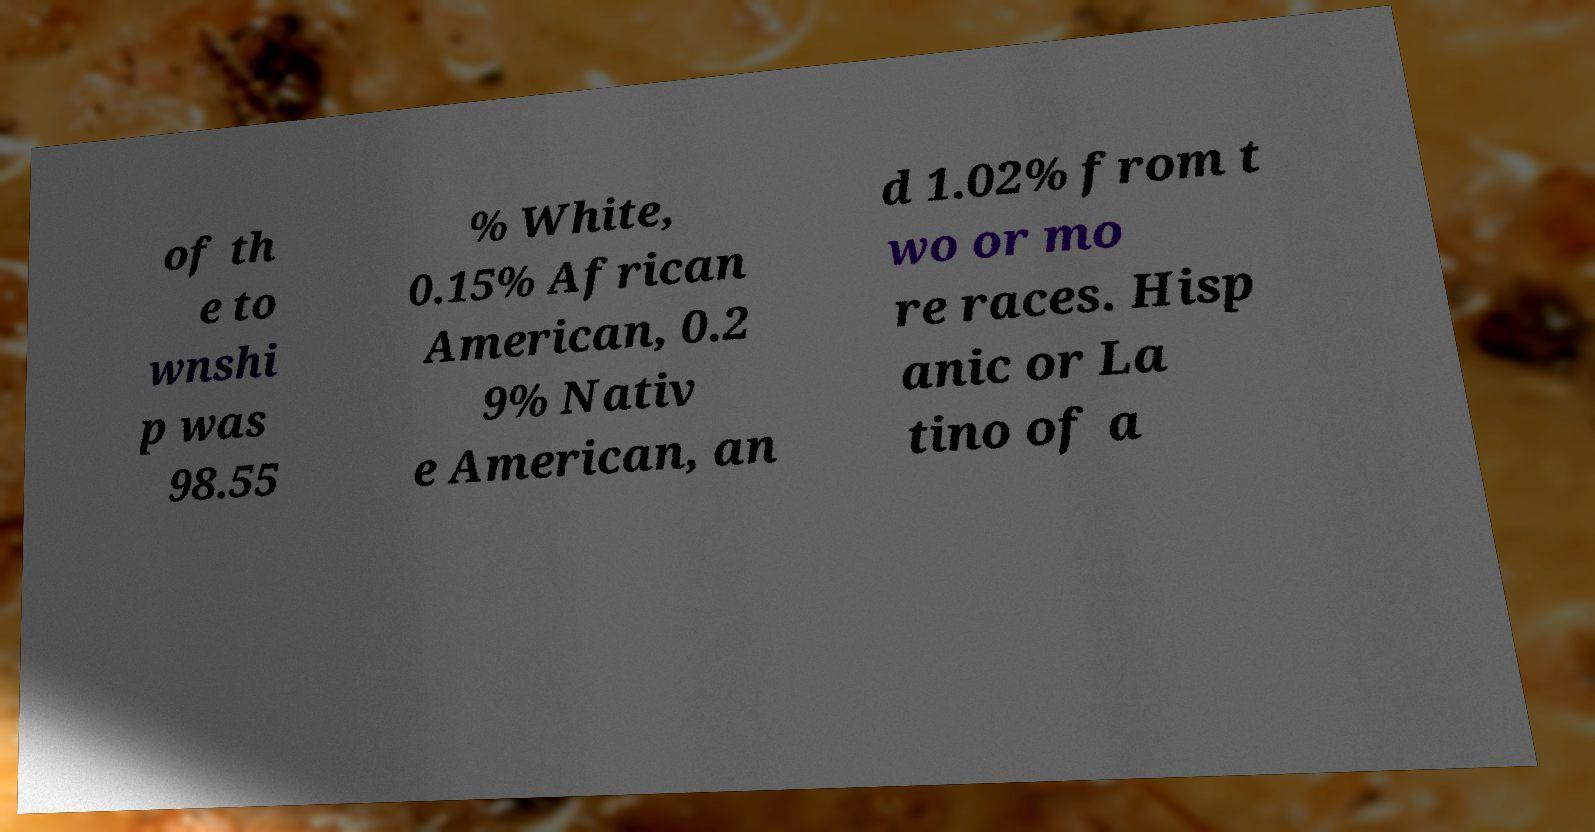There's text embedded in this image that I need extracted. Can you transcribe it verbatim? of th e to wnshi p was 98.55 % White, 0.15% African American, 0.2 9% Nativ e American, an d 1.02% from t wo or mo re races. Hisp anic or La tino of a 